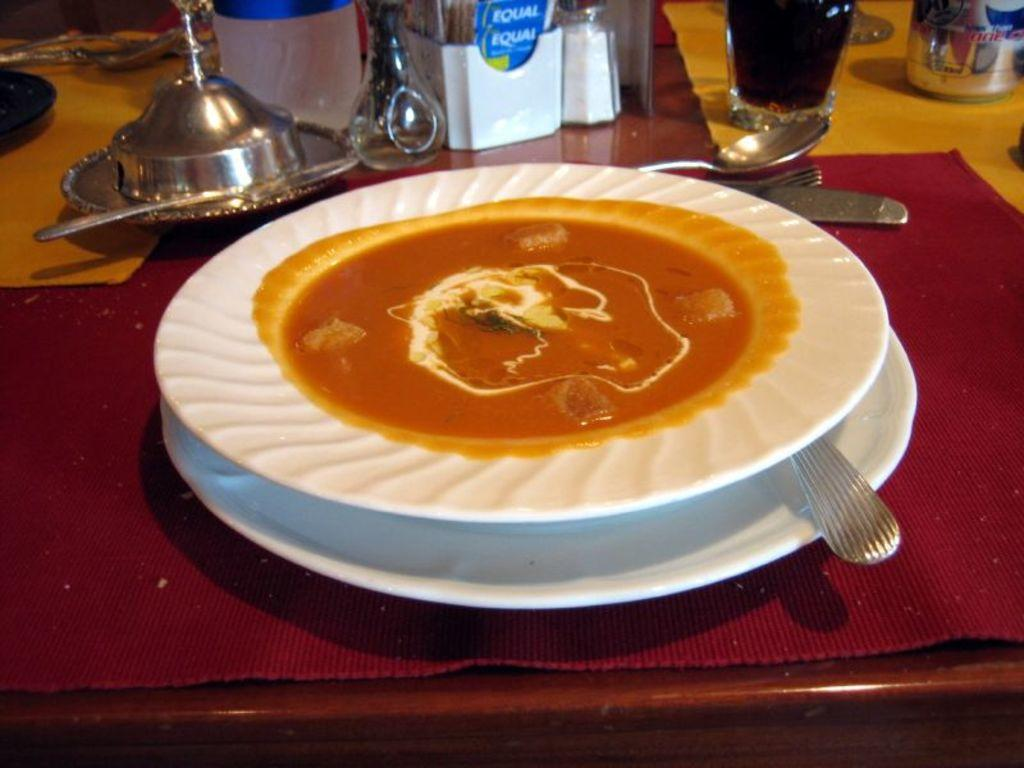What type of food item is on the plate in the image? The provided facts do not specify the type of food item on the plate. What utensils can be seen in the image? Spoons, forks, and knives are visible in the image. Are there any other objects on the table in the image? Yes, there are additional objects on the table in the image. Can you see a ghost interacting with the food item on the plate in the image? No, there is no ghost present in the image. 